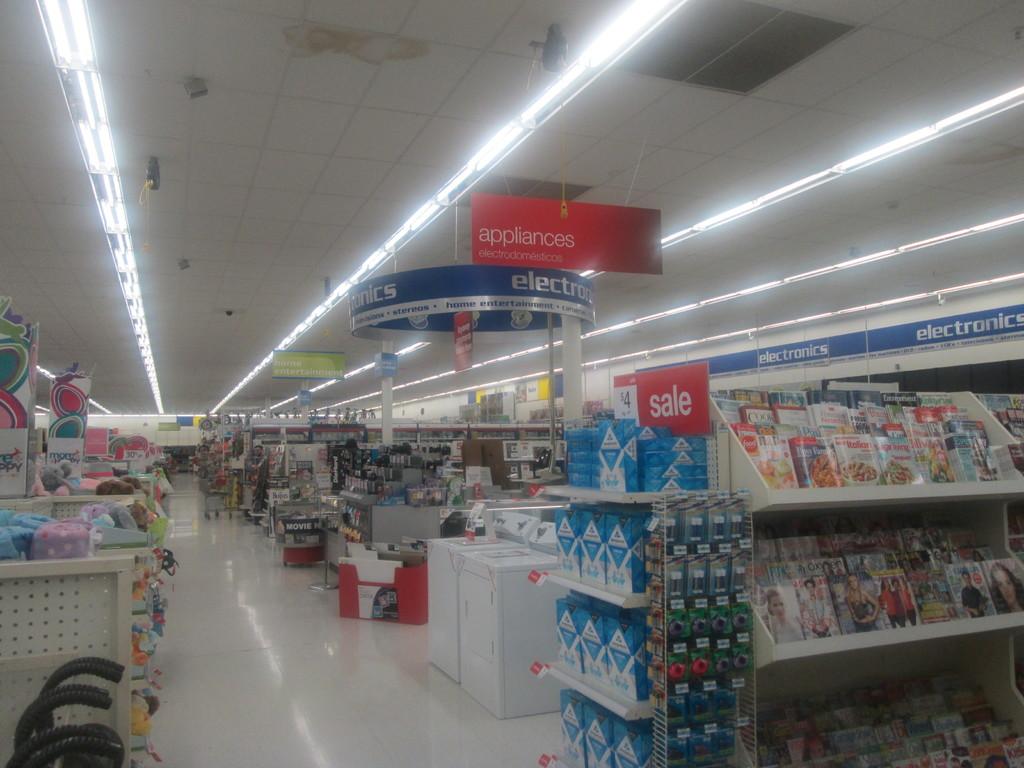What can be purchased under the blue sign?
Offer a terse response. Electronics. 